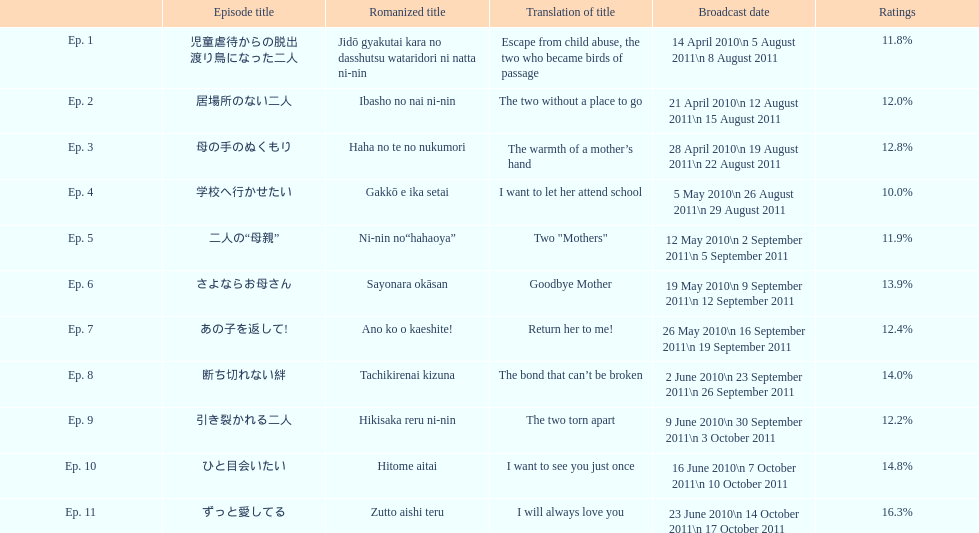What was the succeeding episode's title after "goodbye mother"? あの子を返して!. 